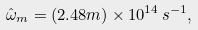Convert formula to latex. <formula><loc_0><loc_0><loc_500><loc_500>\hat { \omega } _ { m } = ( 2 . 4 8 m ) \times 1 0 ^ { 1 4 } \, s ^ { - 1 } ,</formula> 